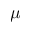<formula> <loc_0><loc_0><loc_500><loc_500>\mu</formula> 